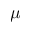<formula> <loc_0><loc_0><loc_500><loc_500>\mu</formula> 